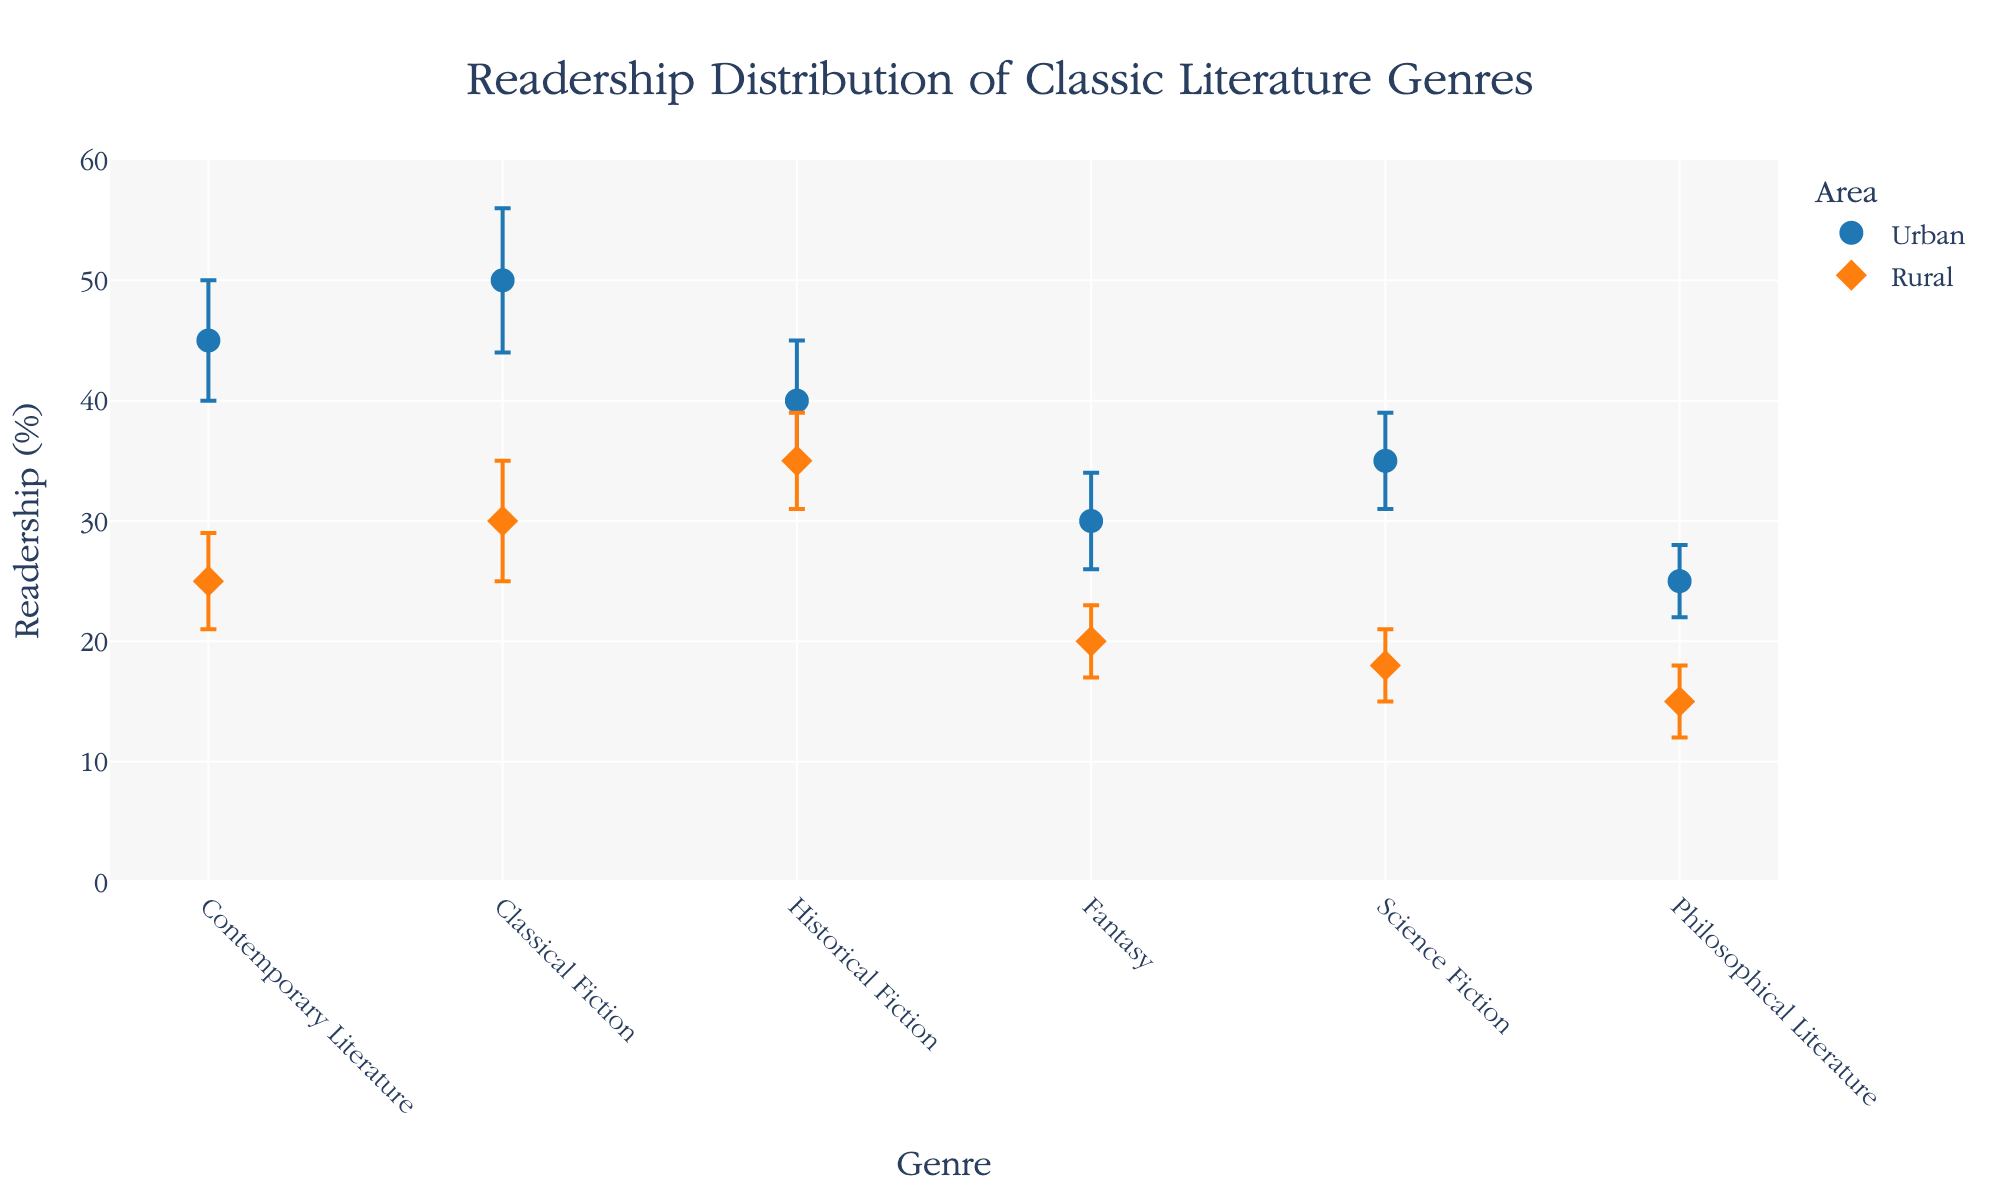What's the title of the figure? The title is placed at the top of the figure. It reads, "Readership Distribution of Classic Literature Genres."
Answer: Readership Distribution of Classic Literature Genres What are the x-axis and y-axis labels? The labels are found along the x-axis and y-axis of the plot. The x-axis is labeled "Genre," and the y-axis is labeled "Readership (%)."
Answer: Genre, Readership (%) How many data points are shown for each area? Each genre has one data point for the "Urban" area and one for the "Rural" area. Since there are six genres, there are six data points for each area.
Answer: 6 Which area has the higher readership for Contemporary Literature? Comparing the readership values for Urban and Rural areas for Contemporary Literature, we see Urban has 45% while Rural has 25%.
Answer: Urban For which genre is the error margin in the Urban area the highest? The error margin is indicated by error bars. The genre with the highest error bar for Urban areas is Classical Fiction with an error of 6.
Answer: Classical Fiction What is the difference in readership between Urban and Rural areas for Fantasy? The Urban readership for Fantasy is 30%, and the Rural readership is 20%. The difference is calculated as 30% - 20%.
Answer: 10% Which genre has the smallest readership in the Rural area? Looking at the y-axis values for Rural areas, the smallest value is for Philosophical Literature at 15%.
Answer: Philosophical Literature What is the total readership for Historical Fiction when combining data from both areas? The readership for Urban is 40%, and for Rural, it's 35%. Adding these values gives 40% + 35%.
Answer: 75% Which genre shows the least difference in readership between Urban and Rural areas? Calculate the difference in readership for each genre: Historical Fiction shows the smallest difference with Urban at 40% and Rural at 35%, a difference of 5%.
Answer: Historical Fiction How do error margins for Science Fiction compare between Urban and Rural areas? The error margin for Urban is 4, and Rural is 3. Compare these values to find that Urban has a slightly higher error margin.
Answer: Urban 